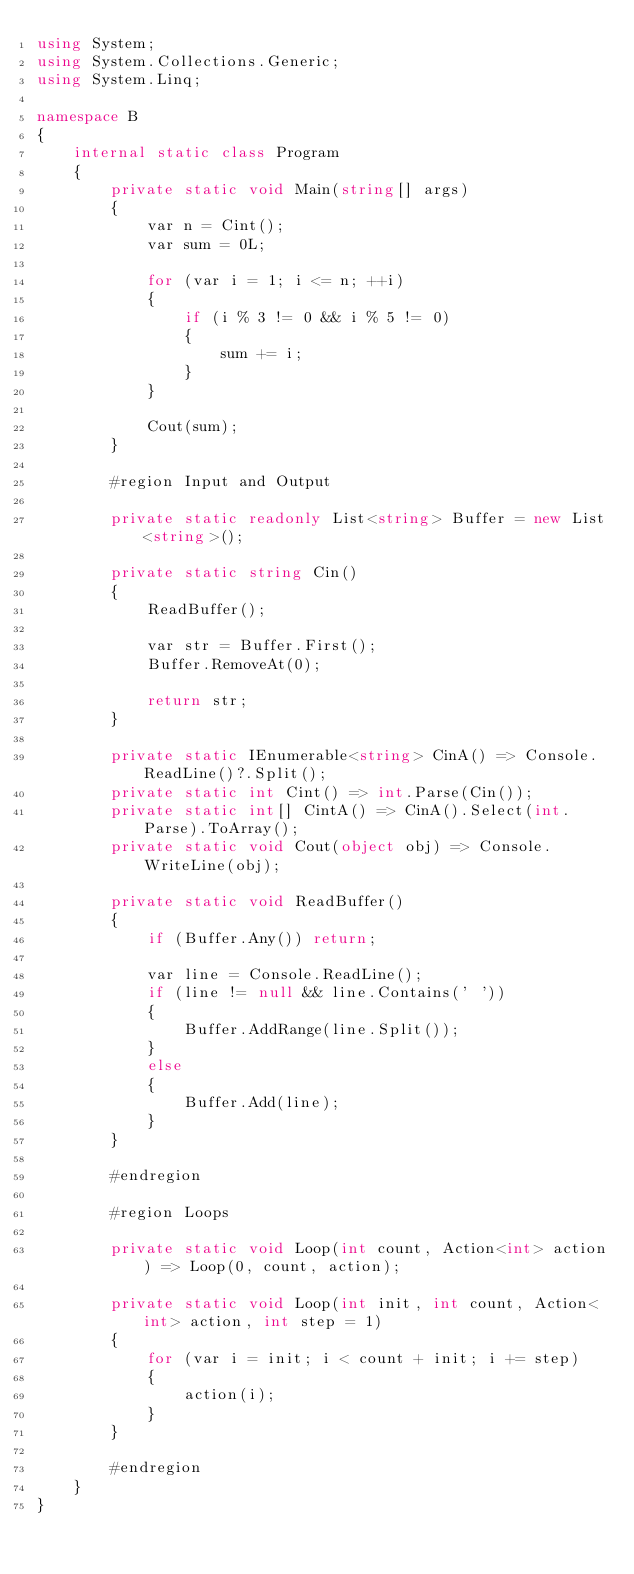Convert code to text. <code><loc_0><loc_0><loc_500><loc_500><_C#_>using System;
using System.Collections.Generic;
using System.Linq;

namespace B
{
    internal static class Program
    {
        private static void Main(string[] args)
        {
            var n = Cint();
            var sum = 0L;

            for (var i = 1; i <= n; ++i)
            {
                if (i % 3 != 0 && i % 5 != 0)
                {
                    sum += i;
                }
            }
            
            Cout(sum);
        }

        #region Input and Output

        private static readonly List<string> Buffer = new List<string>();

        private static string Cin()
        {
            ReadBuffer();

            var str = Buffer.First();
            Buffer.RemoveAt(0);

            return str;
        }

        private static IEnumerable<string> CinA() => Console.ReadLine()?.Split();
        private static int Cint() => int.Parse(Cin());
        private static int[] CintA() => CinA().Select(int.Parse).ToArray();
        private static void Cout(object obj) => Console.WriteLine(obj);

        private static void ReadBuffer()
        {
            if (Buffer.Any()) return;

            var line = Console.ReadLine();
            if (line != null && line.Contains(' '))
            {
                Buffer.AddRange(line.Split());
            }
            else
            {
                Buffer.Add(line);
            }
        }

        #endregion

        #region Loops

        private static void Loop(int count, Action<int> action) => Loop(0, count, action);

        private static void Loop(int init, int count, Action<int> action, int step = 1)
        {
            for (var i = init; i < count + init; i += step)
            {
                action(i);
            }
        }

        #endregion
    }
}
</code> 